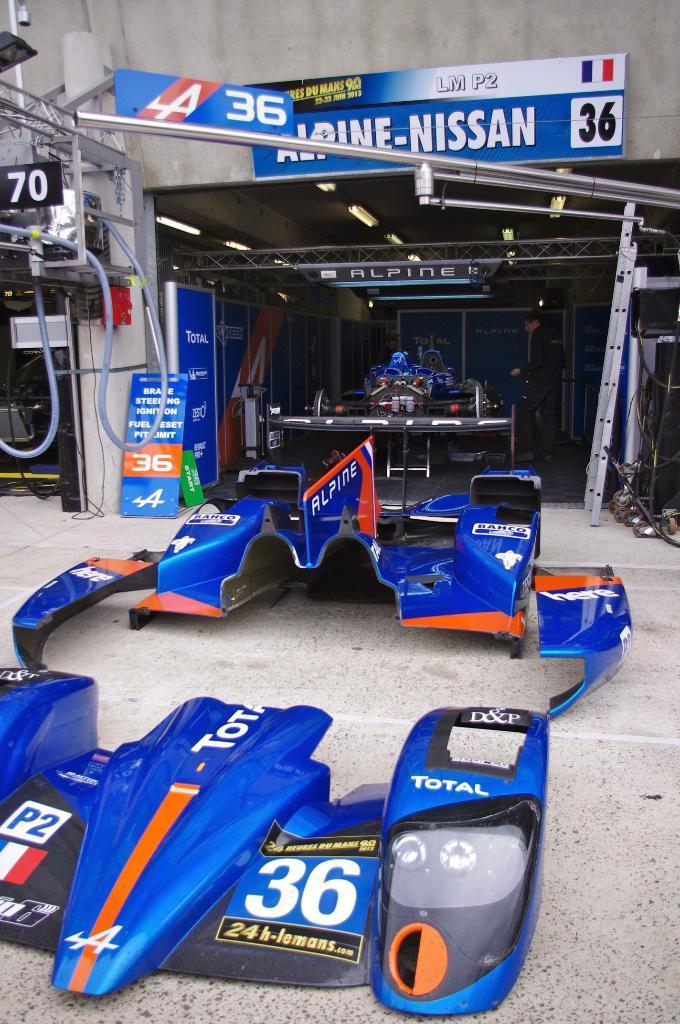How would you summarize this image in a sentence or two? Here I can see few parts of a car on the floor. In the background there is a shed. Under the shed there are many machine tools and few boards on which I can see the text and there are few metal stands. 